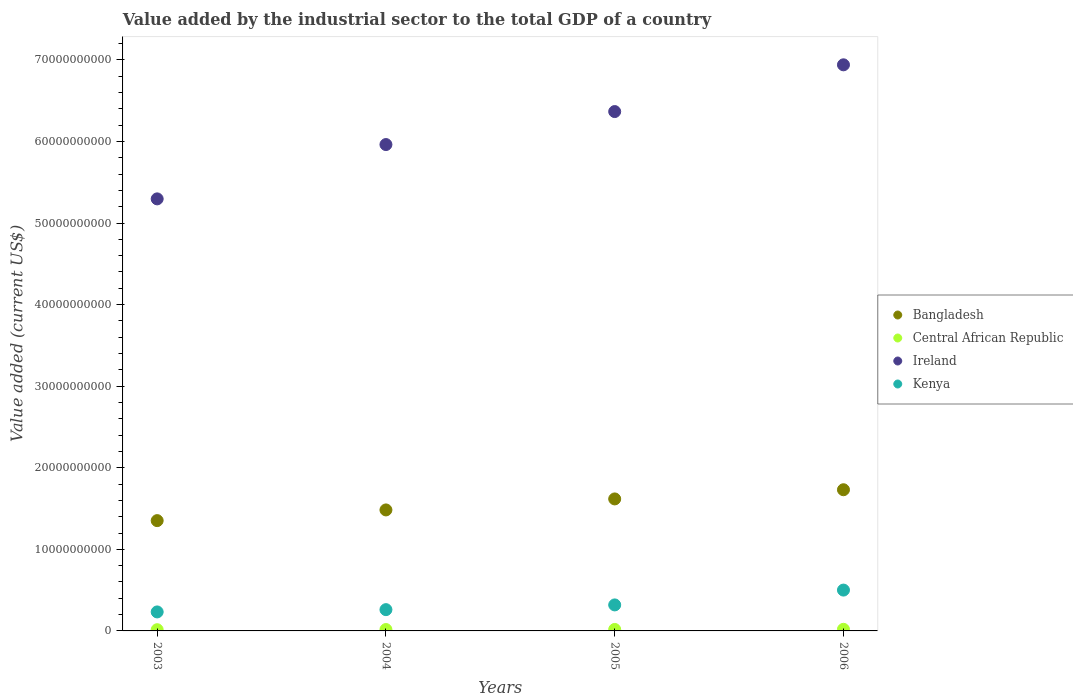How many different coloured dotlines are there?
Make the answer very short. 4. What is the value added by the industrial sector to the total GDP in Ireland in 2003?
Provide a short and direct response. 5.30e+1. Across all years, what is the maximum value added by the industrial sector to the total GDP in Central African Republic?
Ensure brevity in your answer.  1.98e+08. Across all years, what is the minimum value added by the industrial sector to the total GDP in Bangladesh?
Provide a short and direct response. 1.35e+1. In which year was the value added by the industrial sector to the total GDP in Ireland minimum?
Make the answer very short. 2003. What is the total value added by the industrial sector to the total GDP in Bangladesh in the graph?
Your response must be concise. 6.18e+1. What is the difference between the value added by the industrial sector to the total GDP in Kenya in 2004 and that in 2005?
Offer a very short reply. -5.80e+08. What is the difference between the value added by the industrial sector to the total GDP in Kenya in 2004 and the value added by the industrial sector to the total GDP in Ireland in 2003?
Your answer should be very brief. -5.04e+1. What is the average value added by the industrial sector to the total GDP in Kenya per year?
Your response must be concise. 3.28e+09. In the year 2005, what is the difference between the value added by the industrial sector to the total GDP in Kenya and value added by the industrial sector to the total GDP in Bangladesh?
Your response must be concise. -1.30e+1. In how many years, is the value added by the industrial sector to the total GDP in Kenya greater than 2000000000 US$?
Offer a very short reply. 4. What is the ratio of the value added by the industrial sector to the total GDP in Kenya in 2005 to that in 2006?
Ensure brevity in your answer.  0.64. Is the difference between the value added by the industrial sector to the total GDP in Kenya in 2003 and 2005 greater than the difference between the value added by the industrial sector to the total GDP in Bangladesh in 2003 and 2005?
Keep it short and to the point. Yes. What is the difference between the highest and the second highest value added by the industrial sector to the total GDP in Kenya?
Make the answer very short. 1.82e+09. What is the difference between the highest and the lowest value added by the industrial sector to the total GDP in Ireland?
Make the answer very short. 1.64e+1. In how many years, is the value added by the industrial sector to the total GDP in Central African Republic greater than the average value added by the industrial sector to the total GDP in Central African Republic taken over all years?
Your response must be concise. 2. Is it the case that in every year, the sum of the value added by the industrial sector to the total GDP in Bangladesh and value added by the industrial sector to the total GDP in Ireland  is greater than the value added by the industrial sector to the total GDP in Kenya?
Give a very brief answer. Yes. How many dotlines are there?
Make the answer very short. 4. Where does the legend appear in the graph?
Provide a short and direct response. Center right. How many legend labels are there?
Provide a succinct answer. 4. How are the legend labels stacked?
Offer a terse response. Vertical. What is the title of the graph?
Ensure brevity in your answer.  Value added by the industrial sector to the total GDP of a country. What is the label or title of the X-axis?
Provide a succinct answer. Years. What is the label or title of the Y-axis?
Offer a terse response. Value added (current US$). What is the Value added (current US$) in Bangladesh in 2003?
Offer a very short reply. 1.35e+1. What is the Value added (current US$) in Central African Republic in 2003?
Keep it short and to the point. 1.49e+08. What is the Value added (current US$) in Ireland in 2003?
Ensure brevity in your answer.  5.30e+1. What is the Value added (current US$) in Kenya in 2003?
Your response must be concise. 2.33e+09. What is the Value added (current US$) in Bangladesh in 2004?
Make the answer very short. 1.48e+1. What is the Value added (current US$) in Central African Republic in 2004?
Keep it short and to the point. 1.69e+08. What is the Value added (current US$) of Ireland in 2004?
Offer a terse response. 5.96e+1. What is the Value added (current US$) of Kenya in 2004?
Your answer should be very brief. 2.61e+09. What is the Value added (current US$) in Bangladesh in 2005?
Your response must be concise. 1.62e+1. What is the Value added (current US$) of Central African Republic in 2005?
Offer a terse response. 1.81e+08. What is the Value added (current US$) of Ireland in 2005?
Ensure brevity in your answer.  6.37e+1. What is the Value added (current US$) of Kenya in 2005?
Keep it short and to the point. 3.19e+09. What is the Value added (current US$) of Bangladesh in 2006?
Give a very brief answer. 1.73e+1. What is the Value added (current US$) of Central African Republic in 2006?
Make the answer very short. 1.98e+08. What is the Value added (current US$) in Ireland in 2006?
Give a very brief answer. 6.94e+1. What is the Value added (current US$) of Kenya in 2006?
Your response must be concise. 5.01e+09. Across all years, what is the maximum Value added (current US$) of Bangladesh?
Your answer should be compact. 1.73e+1. Across all years, what is the maximum Value added (current US$) in Central African Republic?
Your answer should be very brief. 1.98e+08. Across all years, what is the maximum Value added (current US$) in Ireland?
Provide a succinct answer. 6.94e+1. Across all years, what is the maximum Value added (current US$) of Kenya?
Your answer should be compact. 5.01e+09. Across all years, what is the minimum Value added (current US$) in Bangladesh?
Provide a short and direct response. 1.35e+1. Across all years, what is the minimum Value added (current US$) of Central African Republic?
Ensure brevity in your answer.  1.49e+08. Across all years, what is the minimum Value added (current US$) in Ireland?
Provide a short and direct response. 5.30e+1. Across all years, what is the minimum Value added (current US$) of Kenya?
Provide a short and direct response. 2.33e+09. What is the total Value added (current US$) of Bangladesh in the graph?
Provide a short and direct response. 6.18e+1. What is the total Value added (current US$) of Central African Republic in the graph?
Offer a terse response. 6.97e+08. What is the total Value added (current US$) of Ireland in the graph?
Ensure brevity in your answer.  2.46e+11. What is the total Value added (current US$) of Kenya in the graph?
Provide a succinct answer. 1.31e+1. What is the difference between the Value added (current US$) in Bangladesh in 2003 and that in 2004?
Keep it short and to the point. -1.31e+09. What is the difference between the Value added (current US$) of Central African Republic in 2003 and that in 2004?
Give a very brief answer. -2.04e+07. What is the difference between the Value added (current US$) of Ireland in 2003 and that in 2004?
Provide a short and direct response. -6.66e+09. What is the difference between the Value added (current US$) of Kenya in 2003 and that in 2004?
Your answer should be compact. -2.80e+08. What is the difference between the Value added (current US$) in Bangladesh in 2003 and that in 2005?
Make the answer very short. -2.66e+09. What is the difference between the Value added (current US$) of Central African Republic in 2003 and that in 2005?
Keep it short and to the point. -3.23e+07. What is the difference between the Value added (current US$) in Ireland in 2003 and that in 2005?
Provide a succinct answer. -1.07e+1. What is the difference between the Value added (current US$) in Kenya in 2003 and that in 2005?
Your answer should be compact. -8.59e+08. What is the difference between the Value added (current US$) in Bangladesh in 2003 and that in 2006?
Ensure brevity in your answer.  -3.78e+09. What is the difference between the Value added (current US$) in Central African Republic in 2003 and that in 2006?
Ensure brevity in your answer.  -4.95e+07. What is the difference between the Value added (current US$) in Ireland in 2003 and that in 2006?
Provide a succinct answer. -1.64e+1. What is the difference between the Value added (current US$) in Kenya in 2003 and that in 2006?
Offer a very short reply. -2.68e+09. What is the difference between the Value added (current US$) in Bangladesh in 2004 and that in 2005?
Make the answer very short. -1.35e+09. What is the difference between the Value added (current US$) in Central African Republic in 2004 and that in 2005?
Your response must be concise. -1.20e+07. What is the difference between the Value added (current US$) of Ireland in 2004 and that in 2005?
Keep it short and to the point. -4.04e+09. What is the difference between the Value added (current US$) in Kenya in 2004 and that in 2005?
Your answer should be compact. -5.80e+08. What is the difference between the Value added (current US$) in Bangladesh in 2004 and that in 2006?
Provide a succinct answer. -2.47e+09. What is the difference between the Value added (current US$) in Central African Republic in 2004 and that in 2006?
Give a very brief answer. -2.91e+07. What is the difference between the Value added (current US$) of Ireland in 2004 and that in 2006?
Your response must be concise. -9.77e+09. What is the difference between the Value added (current US$) in Kenya in 2004 and that in 2006?
Keep it short and to the point. -2.40e+09. What is the difference between the Value added (current US$) of Bangladesh in 2005 and that in 2006?
Your response must be concise. -1.12e+09. What is the difference between the Value added (current US$) in Central African Republic in 2005 and that in 2006?
Your answer should be compact. -1.72e+07. What is the difference between the Value added (current US$) in Ireland in 2005 and that in 2006?
Keep it short and to the point. -5.73e+09. What is the difference between the Value added (current US$) of Kenya in 2005 and that in 2006?
Make the answer very short. -1.82e+09. What is the difference between the Value added (current US$) of Bangladesh in 2003 and the Value added (current US$) of Central African Republic in 2004?
Your answer should be very brief. 1.34e+1. What is the difference between the Value added (current US$) of Bangladesh in 2003 and the Value added (current US$) of Ireland in 2004?
Give a very brief answer. -4.61e+1. What is the difference between the Value added (current US$) of Bangladesh in 2003 and the Value added (current US$) of Kenya in 2004?
Provide a short and direct response. 1.09e+1. What is the difference between the Value added (current US$) in Central African Republic in 2003 and the Value added (current US$) in Ireland in 2004?
Provide a short and direct response. -5.95e+1. What is the difference between the Value added (current US$) of Central African Republic in 2003 and the Value added (current US$) of Kenya in 2004?
Make the answer very short. -2.46e+09. What is the difference between the Value added (current US$) of Ireland in 2003 and the Value added (current US$) of Kenya in 2004?
Provide a succinct answer. 5.04e+1. What is the difference between the Value added (current US$) of Bangladesh in 2003 and the Value added (current US$) of Central African Republic in 2005?
Offer a terse response. 1.33e+1. What is the difference between the Value added (current US$) in Bangladesh in 2003 and the Value added (current US$) in Ireland in 2005?
Make the answer very short. -5.01e+1. What is the difference between the Value added (current US$) in Bangladesh in 2003 and the Value added (current US$) in Kenya in 2005?
Offer a terse response. 1.03e+1. What is the difference between the Value added (current US$) in Central African Republic in 2003 and the Value added (current US$) in Ireland in 2005?
Keep it short and to the point. -6.35e+1. What is the difference between the Value added (current US$) in Central African Republic in 2003 and the Value added (current US$) in Kenya in 2005?
Offer a terse response. -3.04e+09. What is the difference between the Value added (current US$) of Ireland in 2003 and the Value added (current US$) of Kenya in 2005?
Provide a short and direct response. 4.98e+1. What is the difference between the Value added (current US$) of Bangladesh in 2003 and the Value added (current US$) of Central African Republic in 2006?
Ensure brevity in your answer.  1.33e+1. What is the difference between the Value added (current US$) in Bangladesh in 2003 and the Value added (current US$) in Ireland in 2006?
Your answer should be very brief. -5.59e+1. What is the difference between the Value added (current US$) of Bangladesh in 2003 and the Value added (current US$) of Kenya in 2006?
Give a very brief answer. 8.51e+09. What is the difference between the Value added (current US$) in Central African Republic in 2003 and the Value added (current US$) in Ireland in 2006?
Provide a succinct answer. -6.92e+1. What is the difference between the Value added (current US$) of Central African Republic in 2003 and the Value added (current US$) of Kenya in 2006?
Your response must be concise. -4.86e+09. What is the difference between the Value added (current US$) of Ireland in 2003 and the Value added (current US$) of Kenya in 2006?
Offer a very short reply. 4.80e+1. What is the difference between the Value added (current US$) of Bangladesh in 2004 and the Value added (current US$) of Central African Republic in 2005?
Keep it short and to the point. 1.47e+1. What is the difference between the Value added (current US$) in Bangladesh in 2004 and the Value added (current US$) in Ireland in 2005?
Keep it short and to the point. -4.88e+1. What is the difference between the Value added (current US$) in Bangladesh in 2004 and the Value added (current US$) in Kenya in 2005?
Make the answer very short. 1.16e+1. What is the difference between the Value added (current US$) in Central African Republic in 2004 and the Value added (current US$) in Ireland in 2005?
Keep it short and to the point. -6.35e+1. What is the difference between the Value added (current US$) in Central African Republic in 2004 and the Value added (current US$) in Kenya in 2005?
Offer a terse response. -3.02e+09. What is the difference between the Value added (current US$) in Ireland in 2004 and the Value added (current US$) in Kenya in 2005?
Provide a short and direct response. 5.64e+1. What is the difference between the Value added (current US$) in Bangladesh in 2004 and the Value added (current US$) in Central African Republic in 2006?
Make the answer very short. 1.46e+1. What is the difference between the Value added (current US$) of Bangladesh in 2004 and the Value added (current US$) of Ireland in 2006?
Provide a short and direct response. -5.46e+1. What is the difference between the Value added (current US$) in Bangladesh in 2004 and the Value added (current US$) in Kenya in 2006?
Your answer should be compact. 9.83e+09. What is the difference between the Value added (current US$) of Central African Republic in 2004 and the Value added (current US$) of Ireland in 2006?
Keep it short and to the point. -6.92e+1. What is the difference between the Value added (current US$) of Central African Republic in 2004 and the Value added (current US$) of Kenya in 2006?
Provide a succinct answer. -4.84e+09. What is the difference between the Value added (current US$) of Ireland in 2004 and the Value added (current US$) of Kenya in 2006?
Your answer should be compact. 5.46e+1. What is the difference between the Value added (current US$) of Bangladesh in 2005 and the Value added (current US$) of Central African Republic in 2006?
Your answer should be compact. 1.60e+1. What is the difference between the Value added (current US$) in Bangladesh in 2005 and the Value added (current US$) in Ireland in 2006?
Your response must be concise. -5.32e+1. What is the difference between the Value added (current US$) of Bangladesh in 2005 and the Value added (current US$) of Kenya in 2006?
Your answer should be compact. 1.12e+1. What is the difference between the Value added (current US$) of Central African Republic in 2005 and the Value added (current US$) of Ireland in 2006?
Make the answer very short. -6.92e+1. What is the difference between the Value added (current US$) in Central African Republic in 2005 and the Value added (current US$) in Kenya in 2006?
Keep it short and to the point. -4.82e+09. What is the difference between the Value added (current US$) in Ireland in 2005 and the Value added (current US$) in Kenya in 2006?
Keep it short and to the point. 5.87e+1. What is the average Value added (current US$) of Bangladesh per year?
Provide a succinct answer. 1.55e+1. What is the average Value added (current US$) in Central African Republic per year?
Your answer should be compact. 1.74e+08. What is the average Value added (current US$) in Ireland per year?
Make the answer very short. 6.14e+1. What is the average Value added (current US$) of Kenya per year?
Offer a terse response. 3.28e+09. In the year 2003, what is the difference between the Value added (current US$) of Bangladesh and Value added (current US$) of Central African Republic?
Your answer should be compact. 1.34e+1. In the year 2003, what is the difference between the Value added (current US$) in Bangladesh and Value added (current US$) in Ireland?
Offer a terse response. -3.94e+1. In the year 2003, what is the difference between the Value added (current US$) of Bangladesh and Value added (current US$) of Kenya?
Your response must be concise. 1.12e+1. In the year 2003, what is the difference between the Value added (current US$) of Central African Republic and Value added (current US$) of Ireland?
Keep it short and to the point. -5.28e+1. In the year 2003, what is the difference between the Value added (current US$) in Central African Republic and Value added (current US$) in Kenya?
Make the answer very short. -2.18e+09. In the year 2003, what is the difference between the Value added (current US$) of Ireland and Value added (current US$) of Kenya?
Give a very brief answer. 5.06e+1. In the year 2004, what is the difference between the Value added (current US$) in Bangladesh and Value added (current US$) in Central African Republic?
Keep it short and to the point. 1.47e+1. In the year 2004, what is the difference between the Value added (current US$) in Bangladesh and Value added (current US$) in Ireland?
Your answer should be compact. -4.48e+1. In the year 2004, what is the difference between the Value added (current US$) in Bangladesh and Value added (current US$) in Kenya?
Provide a succinct answer. 1.22e+1. In the year 2004, what is the difference between the Value added (current US$) of Central African Republic and Value added (current US$) of Ireland?
Your answer should be compact. -5.94e+1. In the year 2004, what is the difference between the Value added (current US$) of Central African Republic and Value added (current US$) of Kenya?
Your response must be concise. -2.44e+09. In the year 2004, what is the difference between the Value added (current US$) of Ireland and Value added (current US$) of Kenya?
Your response must be concise. 5.70e+1. In the year 2005, what is the difference between the Value added (current US$) of Bangladesh and Value added (current US$) of Central African Republic?
Keep it short and to the point. 1.60e+1. In the year 2005, what is the difference between the Value added (current US$) of Bangladesh and Value added (current US$) of Ireland?
Your answer should be compact. -4.75e+1. In the year 2005, what is the difference between the Value added (current US$) in Bangladesh and Value added (current US$) in Kenya?
Your response must be concise. 1.30e+1. In the year 2005, what is the difference between the Value added (current US$) of Central African Republic and Value added (current US$) of Ireland?
Ensure brevity in your answer.  -6.35e+1. In the year 2005, what is the difference between the Value added (current US$) of Central African Republic and Value added (current US$) of Kenya?
Your response must be concise. -3.01e+09. In the year 2005, what is the difference between the Value added (current US$) of Ireland and Value added (current US$) of Kenya?
Keep it short and to the point. 6.05e+1. In the year 2006, what is the difference between the Value added (current US$) of Bangladesh and Value added (current US$) of Central African Republic?
Keep it short and to the point. 1.71e+1. In the year 2006, what is the difference between the Value added (current US$) in Bangladesh and Value added (current US$) in Ireland?
Provide a succinct answer. -5.21e+1. In the year 2006, what is the difference between the Value added (current US$) in Bangladesh and Value added (current US$) in Kenya?
Provide a succinct answer. 1.23e+1. In the year 2006, what is the difference between the Value added (current US$) of Central African Republic and Value added (current US$) of Ireland?
Your response must be concise. -6.92e+1. In the year 2006, what is the difference between the Value added (current US$) of Central African Republic and Value added (current US$) of Kenya?
Your answer should be compact. -4.81e+09. In the year 2006, what is the difference between the Value added (current US$) in Ireland and Value added (current US$) in Kenya?
Your answer should be compact. 6.44e+1. What is the ratio of the Value added (current US$) in Bangladesh in 2003 to that in 2004?
Your answer should be compact. 0.91. What is the ratio of the Value added (current US$) of Central African Republic in 2003 to that in 2004?
Make the answer very short. 0.88. What is the ratio of the Value added (current US$) in Ireland in 2003 to that in 2004?
Your answer should be compact. 0.89. What is the ratio of the Value added (current US$) in Kenya in 2003 to that in 2004?
Make the answer very short. 0.89. What is the ratio of the Value added (current US$) in Bangladesh in 2003 to that in 2005?
Your answer should be very brief. 0.84. What is the ratio of the Value added (current US$) of Central African Republic in 2003 to that in 2005?
Provide a succinct answer. 0.82. What is the ratio of the Value added (current US$) in Ireland in 2003 to that in 2005?
Provide a succinct answer. 0.83. What is the ratio of the Value added (current US$) in Kenya in 2003 to that in 2005?
Provide a succinct answer. 0.73. What is the ratio of the Value added (current US$) of Bangladesh in 2003 to that in 2006?
Keep it short and to the point. 0.78. What is the ratio of the Value added (current US$) in Central African Republic in 2003 to that in 2006?
Offer a terse response. 0.75. What is the ratio of the Value added (current US$) in Ireland in 2003 to that in 2006?
Offer a very short reply. 0.76. What is the ratio of the Value added (current US$) in Kenya in 2003 to that in 2006?
Give a very brief answer. 0.47. What is the ratio of the Value added (current US$) of Central African Republic in 2004 to that in 2005?
Your answer should be very brief. 0.93. What is the ratio of the Value added (current US$) of Ireland in 2004 to that in 2005?
Provide a short and direct response. 0.94. What is the ratio of the Value added (current US$) of Kenya in 2004 to that in 2005?
Make the answer very short. 0.82. What is the ratio of the Value added (current US$) of Bangladesh in 2004 to that in 2006?
Provide a succinct answer. 0.86. What is the ratio of the Value added (current US$) in Central African Republic in 2004 to that in 2006?
Keep it short and to the point. 0.85. What is the ratio of the Value added (current US$) in Ireland in 2004 to that in 2006?
Provide a succinct answer. 0.86. What is the ratio of the Value added (current US$) in Kenya in 2004 to that in 2006?
Your answer should be compact. 0.52. What is the ratio of the Value added (current US$) of Bangladesh in 2005 to that in 2006?
Make the answer very short. 0.94. What is the ratio of the Value added (current US$) in Central African Republic in 2005 to that in 2006?
Offer a terse response. 0.91. What is the ratio of the Value added (current US$) of Ireland in 2005 to that in 2006?
Keep it short and to the point. 0.92. What is the ratio of the Value added (current US$) of Kenya in 2005 to that in 2006?
Your answer should be compact. 0.64. What is the difference between the highest and the second highest Value added (current US$) in Bangladesh?
Offer a very short reply. 1.12e+09. What is the difference between the highest and the second highest Value added (current US$) in Central African Republic?
Offer a very short reply. 1.72e+07. What is the difference between the highest and the second highest Value added (current US$) of Ireland?
Your response must be concise. 5.73e+09. What is the difference between the highest and the second highest Value added (current US$) in Kenya?
Ensure brevity in your answer.  1.82e+09. What is the difference between the highest and the lowest Value added (current US$) in Bangladesh?
Provide a short and direct response. 3.78e+09. What is the difference between the highest and the lowest Value added (current US$) of Central African Republic?
Your answer should be compact. 4.95e+07. What is the difference between the highest and the lowest Value added (current US$) of Ireland?
Your answer should be very brief. 1.64e+1. What is the difference between the highest and the lowest Value added (current US$) of Kenya?
Keep it short and to the point. 2.68e+09. 